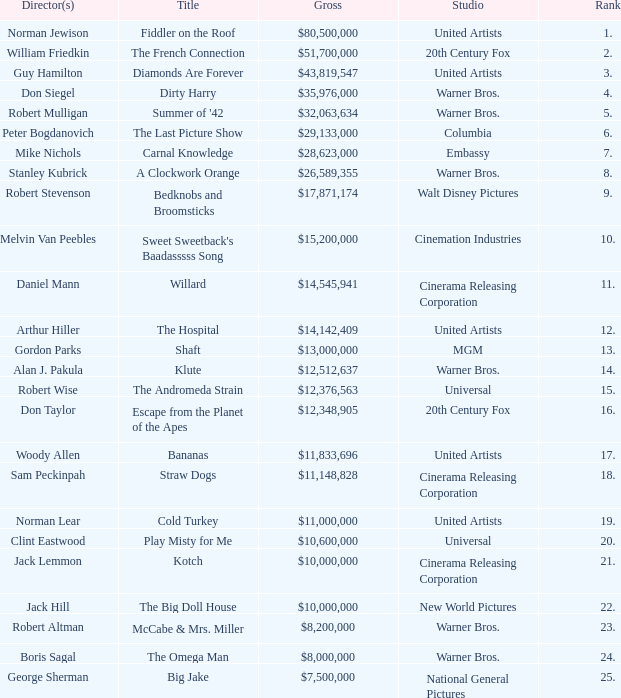What rank has a gross of $35,976,000? 4.0. 